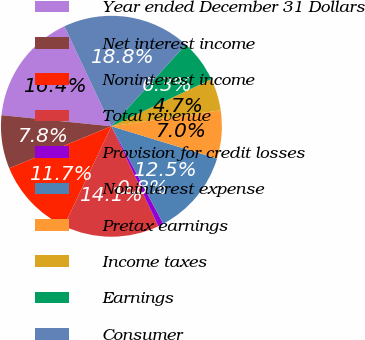Convert chart to OTSL. <chart><loc_0><loc_0><loc_500><loc_500><pie_chart><fcel>Year ended December 31 Dollars<fcel>Net interest income<fcel>Noninterest income<fcel>Total revenue<fcel>Provision for credit losses<fcel>Noninterest expense<fcel>Pretax earnings<fcel>Income taxes<fcel>Earnings<fcel>Consumer<nl><fcel>16.4%<fcel>7.81%<fcel>11.72%<fcel>14.06%<fcel>0.78%<fcel>12.5%<fcel>7.03%<fcel>4.69%<fcel>6.25%<fcel>18.75%<nl></chart> 